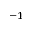<formula> <loc_0><loc_0><loc_500><loc_500>^ { - 1 }</formula> 